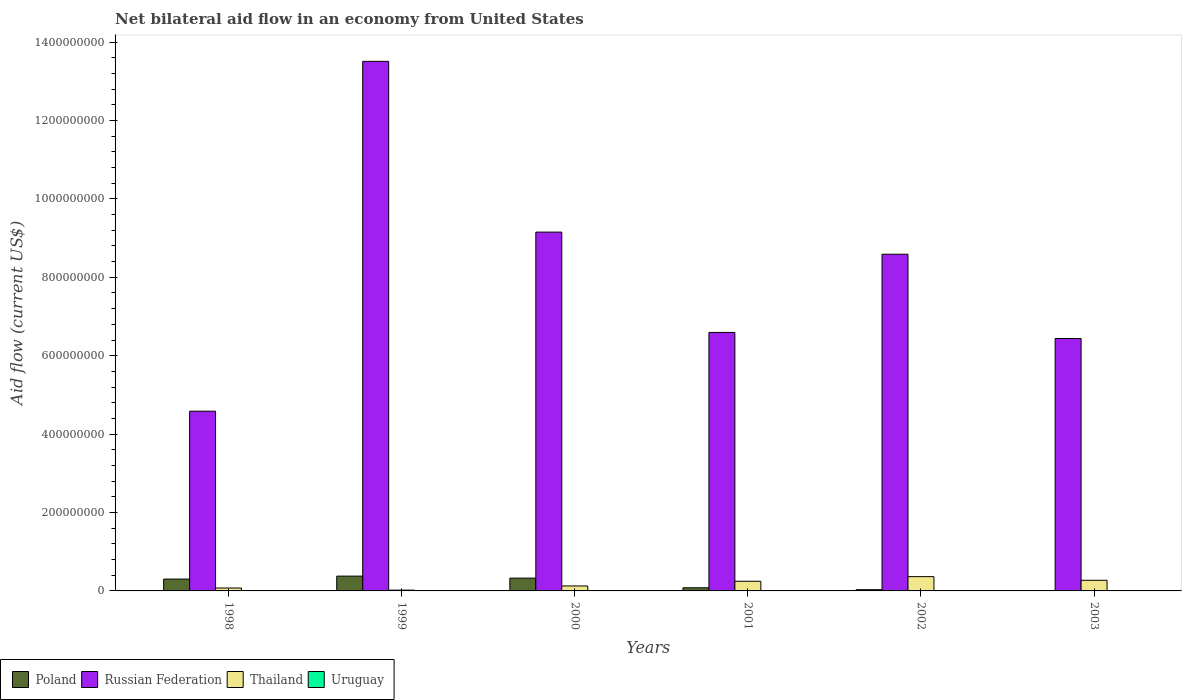How many bars are there on the 4th tick from the left?
Make the answer very short. 3. How many bars are there on the 3rd tick from the right?
Offer a terse response. 3. What is the label of the 2nd group of bars from the left?
Give a very brief answer. 1999. In how many cases, is the number of bars for a given year not equal to the number of legend labels?
Offer a terse response. 3. What is the net bilateral aid flow in Poland in 2001?
Your answer should be compact. 7.97e+06. Across all years, what is the maximum net bilateral aid flow in Poland?
Make the answer very short. 3.77e+07. Across all years, what is the minimum net bilateral aid flow in Poland?
Give a very brief answer. 8.60e+05. What is the total net bilateral aid flow in Thailand in the graph?
Ensure brevity in your answer.  1.10e+08. What is the difference between the net bilateral aid flow in Thailand in 2000 and that in 2001?
Make the answer very short. -1.20e+07. What is the difference between the net bilateral aid flow in Poland in 1998 and the net bilateral aid flow in Thailand in 1999?
Give a very brief answer. 2.82e+07. What is the average net bilateral aid flow in Uruguay per year?
Keep it short and to the point. 2.08e+05. In the year 1998, what is the difference between the net bilateral aid flow in Uruguay and net bilateral aid flow in Thailand?
Your answer should be very brief. -6.91e+06. In how many years, is the net bilateral aid flow in Uruguay greater than 200000000 US$?
Provide a succinct answer. 0. What is the ratio of the net bilateral aid flow in Russian Federation in 2000 to that in 2002?
Your answer should be compact. 1.07. What is the difference between the highest and the second highest net bilateral aid flow in Poland?
Provide a short and direct response. 5.07e+06. What is the difference between the highest and the lowest net bilateral aid flow in Poland?
Offer a very short reply. 3.69e+07. In how many years, is the net bilateral aid flow in Uruguay greater than the average net bilateral aid flow in Uruguay taken over all years?
Keep it short and to the point. 3. Is the sum of the net bilateral aid flow in Poland in 1999 and 2000 greater than the maximum net bilateral aid flow in Russian Federation across all years?
Offer a very short reply. No. Is it the case that in every year, the sum of the net bilateral aid flow in Uruguay and net bilateral aid flow in Thailand is greater than the sum of net bilateral aid flow in Russian Federation and net bilateral aid flow in Poland?
Your response must be concise. No. How many years are there in the graph?
Your response must be concise. 6. Are the values on the major ticks of Y-axis written in scientific E-notation?
Provide a short and direct response. No. Where does the legend appear in the graph?
Your answer should be very brief. Bottom left. How many legend labels are there?
Keep it short and to the point. 4. What is the title of the graph?
Give a very brief answer. Net bilateral aid flow in an economy from United States. What is the label or title of the X-axis?
Provide a short and direct response. Years. What is the label or title of the Y-axis?
Your answer should be very brief. Aid flow (current US$). What is the Aid flow (current US$) in Poland in 1998?
Your response must be concise. 3.02e+07. What is the Aid flow (current US$) of Russian Federation in 1998?
Your answer should be compact. 4.58e+08. What is the Aid flow (current US$) of Thailand in 1998?
Provide a succinct answer. 7.39e+06. What is the Aid flow (current US$) in Uruguay in 1998?
Provide a succinct answer. 4.80e+05. What is the Aid flow (current US$) of Poland in 1999?
Give a very brief answer. 3.77e+07. What is the Aid flow (current US$) in Russian Federation in 1999?
Your answer should be compact. 1.35e+09. What is the Aid flow (current US$) in Thailand in 1999?
Your response must be concise. 2.02e+06. What is the Aid flow (current US$) of Uruguay in 1999?
Provide a short and direct response. 4.30e+05. What is the Aid flow (current US$) of Poland in 2000?
Give a very brief answer. 3.27e+07. What is the Aid flow (current US$) of Russian Federation in 2000?
Your answer should be very brief. 9.15e+08. What is the Aid flow (current US$) of Thailand in 2000?
Make the answer very short. 1.26e+07. What is the Aid flow (current US$) of Uruguay in 2000?
Your answer should be very brief. 3.40e+05. What is the Aid flow (current US$) of Poland in 2001?
Your response must be concise. 7.97e+06. What is the Aid flow (current US$) in Russian Federation in 2001?
Provide a succinct answer. 6.59e+08. What is the Aid flow (current US$) in Thailand in 2001?
Provide a short and direct response. 2.46e+07. What is the Aid flow (current US$) of Uruguay in 2001?
Ensure brevity in your answer.  0. What is the Aid flow (current US$) in Poland in 2002?
Keep it short and to the point. 3.12e+06. What is the Aid flow (current US$) in Russian Federation in 2002?
Keep it short and to the point. 8.59e+08. What is the Aid flow (current US$) of Thailand in 2002?
Offer a very short reply. 3.64e+07. What is the Aid flow (current US$) in Poland in 2003?
Your answer should be very brief. 8.60e+05. What is the Aid flow (current US$) in Russian Federation in 2003?
Provide a succinct answer. 6.44e+08. What is the Aid flow (current US$) in Thailand in 2003?
Make the answer very short. 2.71e+07. What is the Aid flow (current US$) of Uruguay in 2003?
Your response must be concise. 0. Across all years, what is the maximum Aid flow (current US$) in Poland?
Keep it short and to the point. 3.77e+07. Across all years, what is the maximum Aid flow (current US$) in Russian Federation?
Give a very brief answer. 1.35e+09. Across all years, what is the maximum Aid flow (current US$) of Thailand?
Provide a short and direct response. 3.64e+07. Across all years, what is the maximum Aid flow (current US$) of Uruguay?
Offer a very short reply. 4.80e+05. Across all years, what is the minimum Aid flow (current US$) of Poland?
Ensure brevity in your answer.  8.60e+05. Across all years, what is the minimum Aid flow (current US$) of Russian Federation?
Make the answer very short. 4.58e+08. Across all years, what is the minimum Aid flow (current US$) of Thailand?
Your answer should be compact. 2.02e+06. Across all years, what is the minimum Aid flow (current US$) in Uruguay?
Offer a very short reply. 0. What is the total Aid flow (current US$) in Poland in the graph?
Your response must be concise. 1.13e+08. What is the total Aid flow (current US$) in Russian Federation in the graph?
Ensure brevity in your answer.  4.89e+09. What is the total Aid flow (current US$) of Thailand in the graph?
Your answer should be very brief. 1.10e+08. What is the total Aid flow (current US$) of Uruguay in the graph?
Your answer should be very brief. 1.25e+06. What is the difference between the Aid flow (current US$) in Poland in 1998 and that in 1999?
Provide a short and direct response. -7.51e+06. What is the difference between the Aid flow (current US$) in Russian Federation in 1998 and that in 1999?
Provide a succinct answer. -8.92e+08. What is the difference between the Aid flow (current US$) of Thailand in 1998 and that in 1999?
Offer a terse response. 5.37e+06. What is the difference between the Aid flow (current US$) of Uruguay in 1998 and that in 1999?
Offer a very short reply. 5.00e+04. What is the difference between the Aid flow (current US$) in Poland in 1998 and that in 2000?
Offer a very short reply. -2.44e+06. What is the difference between the Aid flow (current US$) of Russian Federation in 1998 and that in 2000?
Provide a short and direct response. -4.57e+08. What is the difference between the Aid flow (current US$) of Thailand in 1998 and that in 2000?
Give a very brief answer. -5.25e+06. What is the difference between the Aid flow (current US$) of Poland in 1998 and that in 2001?
Your answer should be compact. 2.23e+07. What is the difference between the Aid flow (current US$) of Russian Federation in 1998 and that in 2001?
Keep it short and to the point. -2.01e+08. What is the difference between the Aid flow (current US$) of Thailand in 1998 and that in 2001?
Make the answer very short. -1.73e+07. What is the difference between the Aid flow (current US$) of Poland in 1998 and that in 2002?
Make the answer very short. 2.71e+07. What is the difference between the Aid flow (current US$) of Russian Federation in 1998 and that in 2002?
Keep it short and to the point. -4.00e+08. What is the difference between the Aid flow (current US$) in Thailand in 1998 and that in 2002?
Make the answer very short. -2.90e+07. What is the difference between the Aid flow (current US$) of Poland in 1998 and that in 2003?
Keep it short and to the point. 2.94e+07. What is the difference between the Aid flow (current US$) in Russian Federation in 1998 and that in 2003?
Offer a very short reply. -1.85e+08. What is the difference between the Aid flow (current US$) in Thailand in 1998 and that in 2003?
Provide a short and direct response. -1.97e+07. What is the difference between the Aid flow (current US$) in Poland in 1999 and that in 2000?
Your answer should be very brief. 5.07e+06. What is the difference between the Aid flow (current US$) of Russian Federation in 1999 and that in 2000?
Keep it short and to the point. 4.36e+08. What is the difference between the Aid flow (current US$) of Thailand in 1999 and that in 2000?
Offer a very short reply. -1.06e+07. What is the difference between the Aid flow (current US$) in Uruguay in 1999 and that in 2000?
Provide a succinct answer. 9.00e+04. What is the difference between the Aid flow (current US$) of Poland in 1999 and that in 2001?
Make the answer very short. 2.98e+07. What is the difference between the Aid flow (current US$) in Russian Federation in 1999 and that in 2001?
Offer a very short reply. 6.91e+08. What is the difference between the Aid flow (current US$) in Thailand in 1999 and that in 2001?
Keep it short and to the point. -2.26e+07. What is the difference between the Aid flow (current US$) in Poland in 1999 and that in 2002?
Your response must be concise. 3.46e+07. What is the difference between the Aid flow (current US$) in Russian Federation in 1999 and that in 2002?
Your response must be concise. 4.92e+08. What is the difference between the Aid flow (current US$) of Thailand in 1999 and that in 2002?
Keep it short and to the point. -3.44e+07. What is the difference between the Aid flow (current US$) in Poland in 1999 and that in 2003?
Ensure brevity in your answer.  3.69e+07. What is the difference between the Aid flow (current US$) in Russian Federation in 1999 and that in 2003?
Your answer should be very brief. 7.07e+08. What is the difference between the Aid flow (current US$) in Thailand in 1999 and that in 2003?
Give a very brief answer. -2.51e+07. What is the difference between the Aid flow (current US$) of Poland in 2000 and that in 2001?
Offer a very short reply. 2.47e+07. What is the difference between the Aid flow (current US$) of Russian Federation in 2000 and that in 2001?
Your answer should be compact. 2.56e+08. What is the difference between the Aid flow (current US$) of Thailand in 2000 and that in 2001?
Give a very brief answer. -1.20e+07. What is the difference between the Aid flow (current US$) in Poland in 2000 and that in 2002?
Offer a terse response. 2.96e+07. What is the difference between the Aid flow (current US$) in Russian Federation in 2000 and that in 2002?
Your answer should be very brief. 5.64e+07. What is the difference between the Aid flow (current US$) in Thailand in 2000 and that in 2002?
Keep it short and to the point. -2.38e+07. What is the difference between the Aid flow (current US$) of Poland in 2000 and that in 2003?
Keep it short and to the point. 3.18e+07. What is the difference between the Aid flow (current US$) of Russian Federation in 2000 and that in 2003?
Your answer should be compact. 2.71e+08. What is the difference between the Aid flow (current US$) in Thailand in 2000 and that in 2003?
Offer a terse response. -1.45e+07. What is the difference between the Aid flow (current US$) of Poland in 2001 and that in 2002?
Provide a succinct answer. 4.85e+06. What is the difference between the Aid flow (current US$) of Russian Federation in 2001 and that in 2002?
Make the answer very short. -1.99e+08. What is the difference between the Aid flow (current US$) of Thailand in 2001 and that in 2002?
Provide a short and direct response. -1.18e+07. What is the difference between the Aid flow (current US$) of Poland in 2001 and that in 2003?
Provide a short and direct response. 7.11e+06. What is the difference between the Aid flow (current US$) of Russian Federation in 2001 and that in 2003?
Your answer should be very brief. 1.55e+07. What is the difference between the Aid flow (current US$) of Thailand in 2001 and that in 2003?
Offer a very short reply. -2.45e+06. What is the difference between the Aid flow (current US$) in Poland in 2002 and that in 2003?
Provide a succinct answer. 2.26e+06. What is the difference between the Aid flow (current US$) in Russian Federation in 2002 and that in 2003?
Make the answer very short. 2.15e+08. What is the difference between the Aid flow (current US$) of Thailand in 2002 and that in 2003?
Your answer should be compact. 9.34e+06. What is the difference between the Aid flow (current US$) of Poland in 1998 and the Aid flow (current US$) of Russian Federation in 1999?
Offer a very short reply. -1.32e+09. What is the difference between the Aid flow (current US$) in Poland in 1998 and the Aid flow (current US$) in Thailand in 1999?
Your response must be concise. 2.82e+07. What is the difference between the Aid flow (current US$) in Poland in 1998 and the Aid flow (current US$) in Uruguay in 1999?
Provide a succinct answer. 2.98e+07. What is the difference between the Aid flow (current US$) of Russian Federation in 1998 and the Aid flow (current US$) of Thailand in 1999?
Ensure brevity in your answer.  4.56e+08. What is the difference between the Aid flow (current US$) in Russian Federation in 1998 and the Aid flow (current US$) in Uruguay in 1999?
Your answer should be very brief. 4.58e+08. What is the difference between the Aid flow (current US$) of Thailand in 1998 and the Aid flow (current US$) of Uruguay in 1999?
Provide a short and direct response. 6.96e+06. What is the difference between the Aid flow (current US$) of Poland in 1998 and the Aid flow (current US$) of Russian Federation in 2000?
Ensure brevity in your answer.  -8.85e+08. What is the difference between the Aid flow (current US$) of Poland in 1998 and the Aid flow (current US$) of Thailand in 2000?
Keep it short and to the point. 1.76e+07. What is the difference between the Aid flow (current US$) of Poland in 1998 and the Aid flow (current US$) of Uruguay in 2000?
Ensure brevity in your answer.  2.99e+07. What is the difference between the Aid flow (current US$) of Russian Federation in 1998 and the Aid flow (current US$) of Thailand in 2000?
Keep it short and to the point. 4.46e+08. What is the difference between the Aid flow (current US$) in Russian Federation in 1998 and the Aid flow (current US$) in Uruguay in 2000?
Keep it short and to the point. 4.58e+08. What is the difference between the Aid flow (current US$) in Thailand in 1998 and the Aid flow (current US$) in Uruguay in 2000?
Make the answer very short. 7.05e+06. What is the difference between the Aid flow (current US$) of Poland in 1998 and the Aid flow (current US$) of Russian Federation in 2001?
Ensure brevity in your answer.  -6.29e+08. What is the difference between the Aid flow (current US$) of Poland in 1998 and the Aid flow (current US$) of Thailand in 2001?
Your response must be concise. 5.58e+06. What is the difference between the Aid flow (current US$) in Russian Federation in 1998 and the Aid flow (current US$) in Thailand in 2001?
Keep it short and to the point. 4.34e+08. What is the difference between the Aid flow (current US$) in Poland in 1998 and the Aid flow (current US$) in Russian Federation in 2002?
Make the answer very short. -8.29e+08. What is the difference between the Aid flow (current US$) of Poland in 1998 and the Aid flow (current US$) of Thailand in 2002?
Your answer should be compact. -6.21e+06. What is the difference between the Aid flow (current US$) in Russian Federation in 1998 and the Aid flow (current US$) in Thailand in 2002?
Offer a terse response. 4.22e+08. What is the difference between the Aid flow (current US$) in Poland in 1998 and the Aid flow (current US$) in Russian Federation in 2003?
Make the answer very short. -6.14e+08. What is the difference between the Aid flow (current US$) of Poland in 1998 and the Aid flow (current US$) of Thailand in 2003?
Give a very brief answer. 3.13e+06. What is the difference between the Aid flow (current US$) of Russian Federation in 1998 and the Aid flow (current US$) of Thailand in 2003?
Give a very brief answer. 4.31e+08. What is the difference between the Aid flow (current US$) of Poland in 1999 and the Aid flow (current US$) of Russian Federation in 2000?
Keep it short and to the point. -8.77e+08. What is the difference between the Aid flow (current US$) in Poland in 1999 and the Aid flow (current US$) in Thailand in 2000?
Your answer should be compact. 2.51e+07. What is the difference between the Aid flow (current US$) of Poland in 1999 and the Aid flow (current US$) of Uruguay in 2000?
Your response must be concise. 3.74e+07. What is the difference between the Aid flow (current US$) of Russian Federation in 1999 and the Aid flow (current US$) of Thailand in 2000?
Provide a succinct answer. 1.34e+09. What is the difference between the Aid flow (current US$) of Russian Federation in 1999 and the Aid flow (current US$) of Uruguay in 2000?
Offer a terse response. 1.35e+09. What is the difference between the Aid flow (current US$) of Thailand in 1999 and the Aid flow (current US$) of Uruguay in 2000?
Ensure brevity in your answer.  1.68e+06. What is the difference between the Aid flow (current US$) in Poland in 1999 and the Aid flow (current US$) in Russian Federation in 2001?
Provide a succinct answer. -6.22e+08. What is the difference between the Aid flow (current US$) in Poland in 1999 and the Aid flow (current US$) in Thailand in 2001?
Your answer should be very brief. 1.31e+07. What is the difference between the Aid flow (current US$) of Russian Federation in 1999 and the Aid flow (current US$) of Thailand in 2001?
Offer a very short reply. 1.33e+09. What is the difference between the Aid flow (current US$) in Poland in 1999 and the Aid flow (current US$) in Russian Federation in 2002?
Ensure brevity in your answer.  -8.21e+08. What is the difference between the Aid flow (current US$) in Poland in 1999 and the Aid flow (current US$) in Thailand in 2002?
Your answer should be compact. 1.30e+06. What is the difference between the Aid flow (current US$) in Russian Federation in 1999 and the Aid flow (current US$) in Thailand in 2002?
Your answer should be compact. 1.31e+09. What is the difference between the Aid flow (current US$) of Poland in 1999 and the Aid flow (current US$) of Russian Federation in 2003?
Offer a terse response. -6.06e+08. What is the difference between the Aid flow (current US$) in Poland in 1999 and the Aid flow (current US$) in Thailand in 2003?
Keep it short and to the point. 1.06e+07. What is the difference between the Aid flow (current US$) of Russian Federation in 1999 and the Aid flow (current US$) of Thailand in 2003?
Keep it short and to the point. 1.32e+09. What is the difference between the Aid flow (current US$) of Poland in 2000 and the Aid flow (current US$) of Russian Federation in 2001?
Keep it short and to the point. -6.27e+08. What is the difference between the Aid flow (current US$) of Poland in 2000 and the Aid flow (current US$) of Thailand in 2001?
Your answer should be compact. 8.02e+06. What is the difference between the Aid flow (current US$) of Russian Federation in 2000 and the Aid flow (current US$) of Thailand in 2001?
Provide a succinct answer. 8.91e+08. What is the difference between the Aid flow (current US$) in Poland in 2000 and the Aid flow (current US$) in Russian Federation in 2002?
Keep it short and to the point. -8.26e+08. What is the difference between the Aid flow (current US$) of Poland in 2000 and the Aid flow (current US$) of Thailand in 2002?
Your answer should be very brief. -3.77e+06. What is the difference between the Aid flow (current US$) of Russian Federation in 2000 and the Aid flow (current US$) of Thailand in 2002?
Provide a succinct answer. 8.79e+08. What is the difference between the Aid flow (current US$) in Poland in 2000 and the Aid flow (current US$) in Russian Federation in 2003?
Offer a terse response. -6.11e+08. What is the difference between the Aid flow (current US$) in Poland in 2000 and the Aid flow (current US$) in Thailand in 2003?
Your answer should be compact. 5.57e+06. What is the difference between the Aid flow (current US$) in Russian Federation in 2000 and the Aid flow (current US$) in Thailand in 2003?
Offer a terse response. 8.88e+08. What is the difference between the Aid flow (current US$) in Poland in 2001 and the Aid flow (current US$) in Russian Federation in 2002?
Your response must be concise. -8.51e+08. What is the difference between the Aid flow (current US$) in Poland in 2001 and the Aid flow (current US$) in Thailand in 2002?
Keep it short and to the point. -2.85e+07. What is the difference between the Aid flow (current US$) of Russian Federation in 2001 and the Aid flow (current US$) of Thailand in 2002?
Your answer should be very brief. 6.23e+08. What is the difference between the Aid flow (current US$) in Poland in 2001 and the Aid flow (current US$) in Russian Federation in 2003?
Your answer should be very brief. -6.36e+08. What is the difference between the Aid flow (current US$) of Poland in 2001 and the Aid flow (current US$) of Thailand in 2003?
Ensure brevity in your answer.  -1.91e+07. What is the difference between the Aid flow (current US$) of Russian Federation in 2001 and the Aid flow (current US$) of Thailand in 2003?
Ensure brevity in your answer.  6.32e+08. What is the difference between the Aid flow (current US$) of Poland in 2002 and the Aid flow (current US$) of Russian Federation in 2003?
Your answer should be very brief. -6.41e+08. What is the difference between the Aid flow (current US$) of Poland in 2002 and the Aid flow (current US$) of Thailand in 2003?
Give a very brief answer. -2.40e+07. What is the difference between the Aid flow (current US$) in Russian Federation in 2002 and the Aid flow (current US$) in Thailand in 2003?
Your response must be concise. 8.32e+08. What is the average Aid flow (current US$) in Poland per year?
Your answer should be very brief. 1.88e+07. What is the average Aid flow (current US$) in Russian Federation per year?
Your answer should be very brief. 8.14e+08. What is the average Aid flow (current US$) of Thailand per year?
Ensure brevity in your answer.  1.84e+07. What is the average Aid flow (current US$) of Uruguay per year?
Make the answer very short. 2.08e+05. In the year 1998, what is the difference between the Aid flow (current US$) in Poland and Aid flow (current US$) in Russian Federation?
Ensure brevity in your answer.  -4.28e+08. In the year 1998, what is the difference between the Aid flow (current US$) in Poland and Aid flow (current US$) in Thailand?
Provide a succinct answer. 2.28e+07. In the year 1998, what is the difference between the Aid flow (current US$) in Poland and Aid flow (current US$) in Uruguay?
Give a very brief answer. 2.98e+07. In the year 1998, what is the difference between the Aid flow (current US$) of Russian Federation and Aid flow (current US$) of Thailand?
Your answer should be compact. 4.51e+08. In the year 1998, what is the difference between the Aid flow (current US$) of Russian Federation and Aid flow (current US$) of Uruguay?
Your response must be concise. 4.58e+08. In the year 1998, what is the difference between the Aid flow (current US$) of Thailand and Aid flow (current US$) of Uruguay?
Your answer should be compact. 6.91e+06. In the year 1999, what is the difference between the Aid flow (current US$) in Poland and Aid flow (current US$) in Russian Federation?
Provide a succinct answer. -1.31e+09. In the year 1999, what is the difference between the Aid flow (current US$) in Poland and Aid flow (current US$) in Thailand?
Your response must be concise. 3.57e+07. In the year 1999, what is the difference between the Aid flow (current US$) in Poland and Aid flow (current US$) in Uruguay?
Your answer should be very brief. 3.73e+07. In the year 1999, what is the difference between the Aid flow (current US$) of Russian Federation and Aid flow (current US$) of Thailand?
Your answer should be very brief. 1.35e+09. In the year 1999, what is the difference between the Aid flow (current US$) in Russian Federation and Aid flow (current US$) in Uruguay?
Your response must be concise. 1.35e+09. In the year 1999, what is the difference between the Aid flow (current US$) of Thailand and Aid flow (current US$) of Uruguay?
Your answer should be very brief. 1.59e+06. In the year 2000, what is the difference between the Aid flow (current US$) in Poland and Aid flow (current US$) in Russian Federation?
Your answer should be very brief. -8.83e+08. In the year 2000, what is the difference between the Aid flow (current US$) in Poland and Aid flow (current US$) in Thailand?
Ensure brevity in your answer.  2.00e+07. In the year 2000, what is the difference between the Aid flow (current US$) of Poland and Aid flow (current US$) of Uruguay?
Provide a succinct answer. 3.23e+07. In the year 2000, what is the difference between the Aid flow (current US$) in Russian Federation and Aid flow (current US$) in Thailand?
Your answer should be very brief. 9.03e+08. In the year 2000, what is the difference between the Aid flow (current US$) in Russian Federation and Aid flow (current US$) in Uruguay?
Make the answer very short. 9.15e+08. In the year 2000, what is the difference between the Aid flow (current US$) of Thailand and Aid flow (current US$) of Uruguay?
Give a very brief answer. 1.23e+07. In the year 2001, what is the difference between the Aid flow (current US$) in Poland and Aid flow (current US$) in Russian Federation?
Your response must be concise. -6.51e+08. In the year 2001, what is the difference between the Aid flow (current US$) of Poland and Aid flow (current US$) of Thailand?
Keep it short and to the point. -1.67e+07. In the year 2001, what is the difference between the Aid flow (current US$) of Russian Federation and Aid flow (current US$) of Thailand?
Provide a short and direct response. 6.35e+08. In the year 2002, what is the difference between the Aid flow (current US$) of Poland and Aid flow (current US$) of Russian Federation?
Make the answer very short. -8.56e+08. In the year 2002, what is the difference between the Aid flow (current US$) of Poland and Aid flow (current US$) of Thailand?
Provide a short and direct response. -3.33e+07. In the year 2002, what is the difference between the Aid flow (current US$) of Russian Federation and Aid flow (current US$) of Thailand?
Make the answer very short. 8.22e+08. In the year 2003, what is the difference between the Aid flow (current US$) in Poland and Aid flow (current US$) in Russian Federation?
Offer a terse response. -6.43e+08. In the year 2003, what is the difference between the Aid flow (current US$) of Poland and Aid flow (current US$) of Thailand?
Ensure brevity in your answer.  -2.62e+07. In the year 2003, what is the difference between the Aid flow (current US$) of Russian Federation and Aid flow (current US$) of Thailand?
Make the answer very short. 6.17e+08. What is the ratio of the Aid flow (current US$) of Poland in 1998 to that in 1999?
Offer a very short reply. 0.8. What is the ratio of the Aid flow (current US$) in Russian Federation in 1998 to that in 1999?
Your answer should be very brief. 0.34. What is the ratio of the Aid flow (current US$) in Thailand in 1998 to that in 1999?
Your response must be concise. 3.66. What is the ratio of the Aid flow (current US$) in Uruguay in 1998 to that in 1999?
Ensure brevity in your answer.  1.12. What is the ratio of the Aid flow (current US$) of Poland in 1998 to that in 2000?
Offer a terse response. 0.93. What is the ratio of the Aid flow (current US$) in Russian Federation in 1998 to that in 2000?
Offer a very short reply. 0.5. What is the ratio of the Aid flow (current US$) of Thailand in 1998 to that in 2000?
Your response must be concise. 0.58. What is the ratio of the Aid flow (current US$) of Uruguay in 1998 to that in 2000?
Provide a succinct answer. 1.41. What is the ratio of the Aid flow (current US$) in Poland in 1998 to that in 2001?
Keep it short and to the point. 3.79. What is the ratio of the Aid flow (current US$) of Russian Federation in 1998 to that in 2001?
Provide a short and direct response. 0.7. What is the ratio of the Aid flow (current US$) of Thailand in 1998 to that in 2001?
Your answer should be compact. 0.3. What is the ratio of the Aid flow (current US$) in Poland in 1998 to that in 2002?
Give a very brief answer. 9.69. What is the ratio of the Aid flow (current US$) of Russian Federation in 1998 to that in 2002?
Offer a terse response. 0.53. What is the ratio of the Aid flow (current US$) of Thailand in 1998 to that in 2002?
Your response must be concise. 0.2. What is the ratio of the Aid flow (current US$) of Poland in 1998 to that in 2003?
Ensure brevity in your answer.  35.15. What is the ratio of the Aid flow (current US$) of Russian Federation in 1998 to that in 2003?
Ensure brevity in your answer.  0.71. What is the ratio of the Aid flow (current US$) of Thailand in 1998 to that in 2003?
Your response must be concise. 0.27. What is the ratio of the Aid flow (current US$) in Poland in 1999 to that in 2000?
Provide a short and direct response. 1.16. What is the ratio of the Aid flow (current US$) of Russian Federation in 1999 to that in 2000?
Provide a succinct answer. 1.48. What is the ratio of the Aid flow (current US$) in Thailand in 1999 to that in 2000?
Provide a short and direct response. 0.16. What is the ratio of the Aid flow (current US$) in Uruguay in 1999 to that in 2000?
Give a very brief answer. 1.26. What is the ratio of the Aid flow (current US$) in Poland in 1999 to that in 2001?
Provide a short and direct response. 4.74. What is the ratio of the Aid flow (current US$) in Russian Federation in 1999 to that in 2001?
Provide a short and direct response. 2.05. What is the ratio of the Aid flow (current US$) in Thailand in 1999 to that in 2001?
Your answer should be very brief. 0.08. What is the ratio of the Aid flow (current US$) in Poland in 1999 to that in 2002?
Your answer should be very brief. 12.1. What is the ratio of the Aid flow (current US$) in Russian Federation in 1999 to that in 2002?
Your response must be concise. 1.57. What is the ratio of the Aid flow (current US$) of Thailand in 1999 to that in 2002?
Keep it short and to the point. 0.06. What is the ratio of the Aid flow (current US$) of Poland in 1999 to that in 2003?
Keep it short and to the point. 43.88. What is the ratio of the Aid flow (current US$) in Russian Federation in 1999 to that in 2003?
Provide a succinct answer. 2.1. What is the ratio of the Aid flow (current US$) in Thailand in 1999 to that in 2003?
Your response must be concise. 0.07. What is the ratio of the Aid flow (current US$) in Poland in 2000 to that in 2001?
Make the answer very short. 4.1. What is the ratio of the Aid flow (current US$) in Russian Federation in 2000 to that in 2001?
Give a very brief answer. 1.39. What is the ratio of the Aid flow (current US$) of Thailand in 2000 to that in 2001?
Provide a succinct answer. 0.51. What is the ratio of the Aid flow (current US$) in Poland in 2000 to that in 2002?
Provide a short and direct response. 10.47. What is the ratio of the Aid flow (current US$) of Russian Federation in 2000 to that in 2002?
Your answer should be compact. 1.07. What is the ratio of the Aid flow (current US$) in Thailand in 2000 to that in 2002?
Keep it short and to the point. 0.35. What is the ratio of the Aid flow (current US$) in Poland in 2000 to that in 2003?
Your response must be concise. 37.99. What is the ratio of the Aid flow (current US$) in Russian Federation in 2000 to that in 2003?
Ensure brevity in your answer.  1.42. What is the ratio of the Aid flow (current US$) in Thailand in 2000 to that in 2003?
Give a very brief answer. 0.47. What is the ratio of the Aid flow (current US$) in Poland in 2001 to that in 2002?
Your answer should be very brief. 2.55. What is the ratio of the Aid flow (current US$) of Russian Federation in 2001 to that in 2002?
Offer a very short reply. 0.77. What is the ratio of the Aid flow (current US$) in Thailand in 2001 to that in 2002?
Offer a terse response. 0.68. What is the ratio of the Aid flow (current US$) in Poland in 2001 to that in 2003?
Make the answer very short. 9.27. What is the ratio of the Aid flow (current US$) in Russian Federation in 2001 to that in 2003?
Your answer should be compact. 1.02. What is the ratio of the Aid flow (current US$) of Thailand in 2001 to that in 2003?
Ensure brevity in your answer.  0.91. What is the ratio of the Aid flow (current US$) in Poland in 2002 to that in 2003?
Offer a very short reply. 3.63. What is the ratio of the Aid flow (current US$) in Russian Federation in 2002 to that in 2003?
Keep it short and to the point. 1.33. What is the ratio of the Aid flow (current US$) in Thailand in 2002 to that in 2003?
Provide a succinct answer. 1.34. What is the difference between the highest and the second highest Aid flow (current US$) in Poland?
Ensure brevity in your answer.  5.07e+06. What is the difference between the highest and the second highest Aid flow (current US$) in Russian Federation?
Provide a succinct answer. 4.36e+08. What is the difference between the highest and the second highest Aid flow (current US$) in Thailand?
Provide a short and direct response. 9.34e+06. What is the difference between the highest and the lowest Aid flow (current US$) in Poland?
Your response must be concise. 3.69e+07. What is the difference between the highest and the lowest Aid flow (current US$) of Russian Federation?
Ensure brevity in your answer.  8.92e+08. What is the difference between the highest and the lowest Aid flow (current US$) in Thailand?
Offer a terse response. 3.44e+07. 